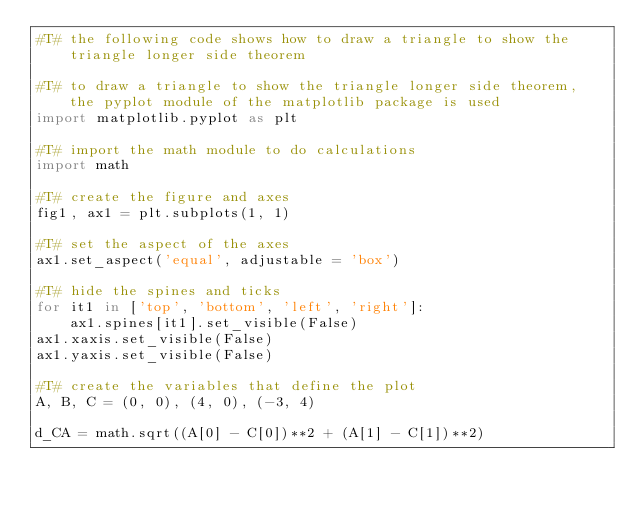Convert code to text. <code><loc_0><loc_0><loc_500><loc_500><_Python_>#T# the following code shows how to draw a triangle to show the triangle longer side theorem

#T# to draw a triangle to show the triangle longer side theorem, the pyplot module of the matplotlib package is used
import matplotlib.pyplot as plt

#T# import the math module to do calculations
import math

#T# create the figure and axes
fig1, ax1 = plt.subplots(1, 1)

#T# set the aspect of the axes
ax1.set_aspect('equal', adjustable = 'box')

#T# hide the spines and ticks
for it1 in ['top', 'bottom', 'left', 'right']:
    ax1.spines[it1].set_visible(False)
ax1.xaxis.set_visible(False)
ax1.yaxis.set_visible(False)

#T# create the variables that define the plot
A, B, C = (0, 0), (4, 0), (-3, 4)

d_CA = math.sqrt((A[0] - C[0])**2 + (A[1] - C[1])**2)</code> 